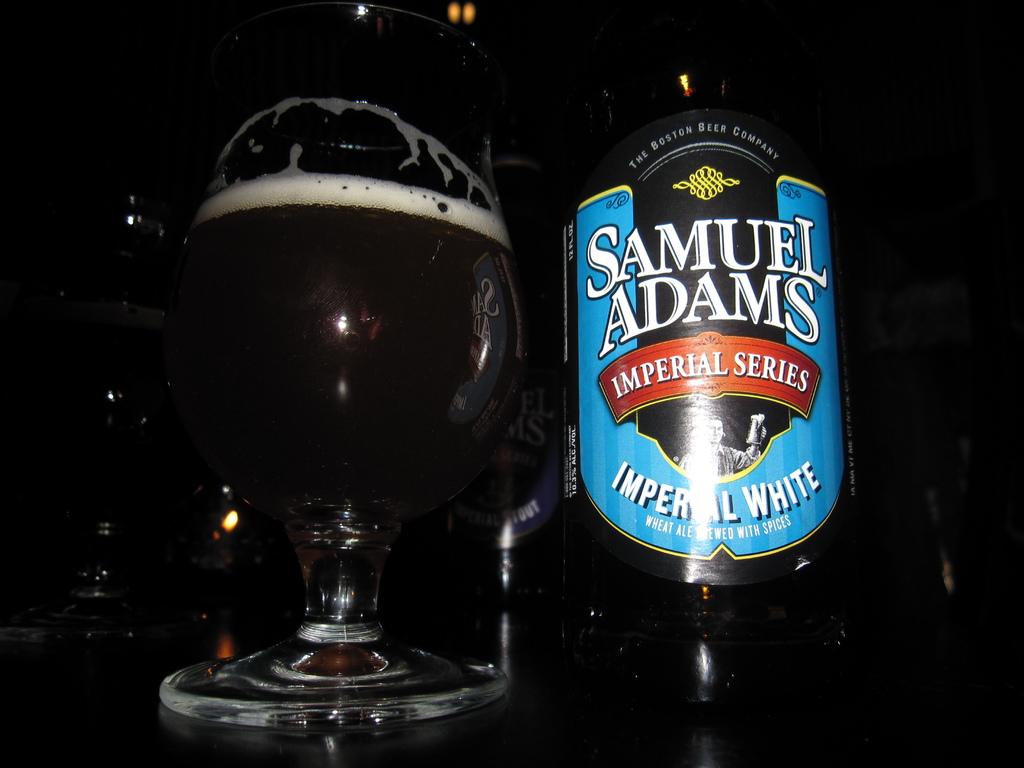What series of samuel adams beer is this?
Ensure brevity in your answer.  Imperial. 